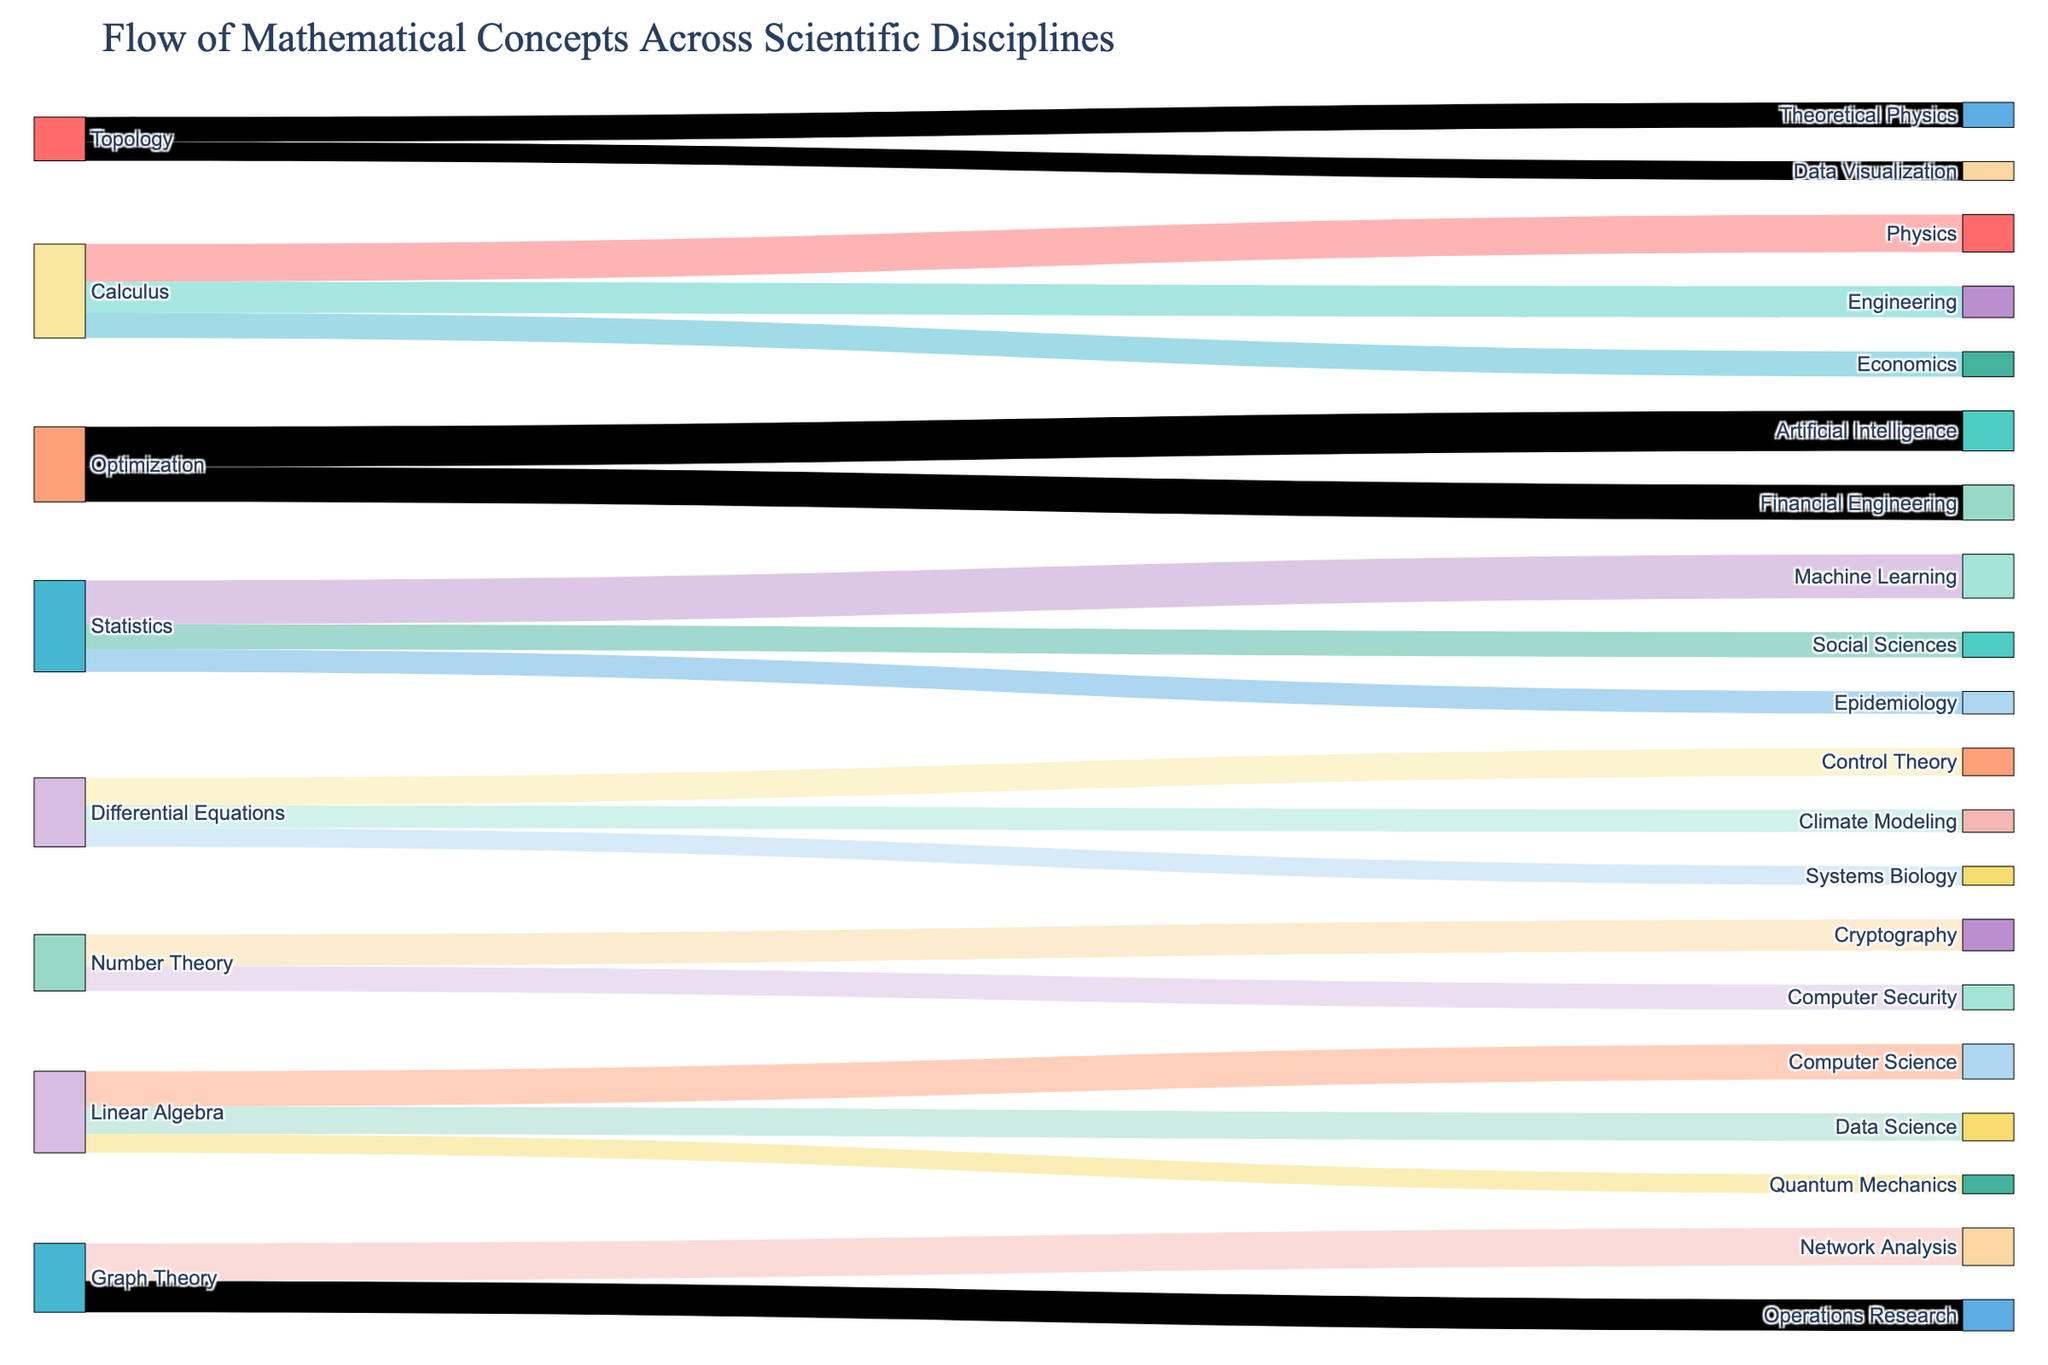what are the two scientific disciplines that use Calculus the most according to the diagram? The diagram shows arrows flowing from "Calculus" to various disciplines. The width of the arrows represents the magnitude of the flow. The widest arrows from "Calculus" go to "Physics" and "Engineering."
Answer: Physics and Engineering What is the least connected mathematical concept in terms of the number of scientific disciplines it applies to? The mathematical concept with connections to the fewest scientific disciplines appears the least frequently as a "Source". "Number Theory" is connected to "Cryptography" and "Computer Security", making it the least connected.
Answer: Number Theory Which mathematical concept has the highest cumulative value of applications across scientific disciplines? To find this, add up the values for each mathematical concept and compare. Calculus: 30+25+20=75; Linear Algebra: 28+22+15=65; Statistics: 35+18+20=73; Number Theory: 25+20=45; Differential Equations: 15+18+22=55; Graph Theory: 30+25=55; Topology: 20+15=35; Optimization: 28+32=60. "Calculus" has the highest cumulative value of 75.
Answer: Calculus Which target discipline receives the most substantial value from its source concepts, and what is the value? Sum the values for each target discipline: Physics: 30; Engineering: 25; Economics: 20; Computer Science: 28+25=53; Data Science: 22; Quantum Mechanics: 15; Machine Learning: 35; Epidemiology: 18; Social Sciences: 20; Cryptography: 25; Computer Security: 20; Systems Biology: 15; Climate Modeling: 18; Control Theory: 22; Network Analysis: 30; Operations Research: 25; Theoretical Physics: 20; Data Visualization: 15; Financial Engineering: 28; Artificial Intelligence: 32. "Machine Learning" receives the most substantial value of 35 from "Statistics" with no other contributions.
Answer: 35 How does the flow value to Data Science from Linear Algebra compare to the flow value to Quantum Mechanics from Linear Algebra? Review the diagram and note the flow values for these relationships. Linear Algebra to Data Science is valued at 22, and to Quantum Mechanics is valued at 15. Compare 22 and 15.
Answer: Data Science from Linear Algebra is 7 more than to Quantum Mechanics Which mathematical concept feeds into Artificial Intelligence and what is the value? Identify the mathematical concepts connected to "Artificial Intelligence". The only connecting concept is "Optimization" with a value of 32.
Answer: Optimization, 32 What is the cumulative value flowing out of "Statistics"? Add up all the flow values from "Statistics" to its target disciplines: 35(Machine Learning) + 18(Epidemiology) + 20(Social Sciences) = 73.
Answer: 73 Compare the value of flow from Calculus to Economics against the value from Topology to Theoretical Physics. Which is higher? Check the values for the respective flows in the diagram. Calculus to Economics is 20, and Topology to Theoretical Physics is 20. Compare 20 to 20.
Answer: They are equal Which discipline receives flow from the most different mathematical concepts? Count the number of unique sources for each target discipline. For example, Computer Science receives from Linear Algebra and Number Theory. "Artificial Intelligence" and "Data Science" receive from distinct mathematical concepts. "Artificial Intelligence" receives values from "Optimization" only. The maximum count per the provided data points is 1.
Answer: Artificial Intelligence Overall, which concept sees the broadest distribution of its applications across scientific disciplines? Calculate the number of target disciplines connected to each mathematical concept. Statistics connects to 3 target disciplines (Machine Learning, Epidemiology, Social Sciences). Calculus also connects to 3 target disciplines (Physics, Engineering, Economics). This variety makes them the broadest distributed.
Answer: Statistics and Calculus 